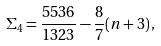Convert formula to latex. <formula><loc_0><loc_0><loc_500><loc_500>\Sigma _ { 4 } = \frac { 5 5 3 6 } { 1 3 2 3 } - \frac { 8 } { 7 } ( n + 3 ) \, ,</formula> 